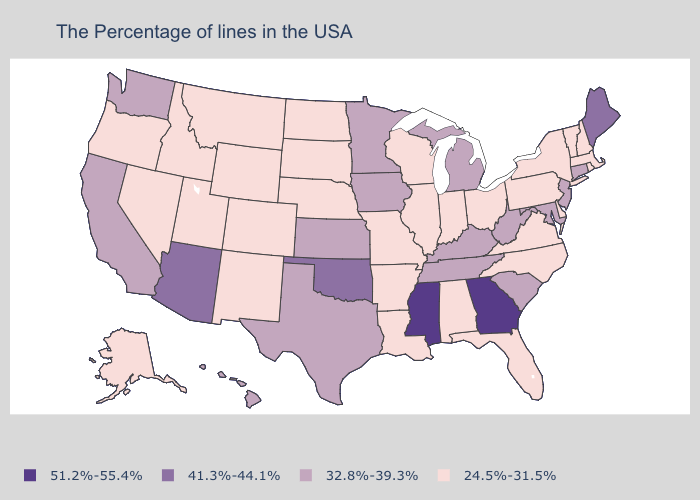Name the states that have a value in the range 24.5%-31.5%?
Keep it brief. Massachusetts, Rhode Island, New Hampshire, Vermont, New York, Delaware, Pennsylvania, Virginia, North Carolina, Ohio, Florida, Indiana, Alabama, Wisconsin, Illinois, Louisiana, Missouri, Arkansas, Nebraska, South Dakota, North Dakota, Wyoming, Colorado, New Mexico, Utah, Montana, Idaho, Nevada, Oregon, Alaska. What is the highest value in states that border Maine?
Short answer required. 24.5%-31.5%. What is the highest value in states that border California?
Answer briefly. 41.3%-44.1%. What is the value of Texas?
Write a very short answer. 32.8%-39.3%. What is the value of Kentucky?
Keep it brief. 32.8%-39.3%. What is the value of Pennsylvania?
Quick response, please. 24.5%-31.5%. What is the value of Massachusetts?
Short answer required. 24.5%-31.5%. What is the lowest value in the West?
Write a very short answer. 24.5%-31.5%. What is the value of Delaware?
Concise answer only. 24.5%-31.5%. What is the value of Oregon?
Keep it brief. 24.5%-31.5%. Name the states that have a value in the range 41.3%-44.1%?
Quick response, please. Maine, Oklahoma, Arizona. Does the first symbol in the legend represent the smallest category?
Quick response, please. No. What is the lowest value in states that border South Carolina?
Concise answer only. 24.5%-31.5%. What is the highest value in states that border Maine?
Keep it brief. 24.5%-31.5%. 